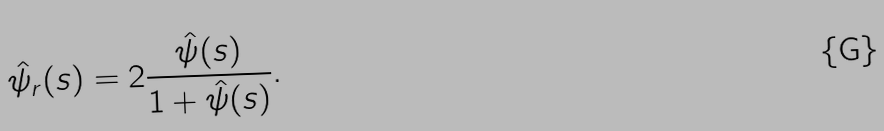<formula> <loc_0><loc_0><loc_500><loc_500>\hat { \psi } _ { r } ( s ) = 2 \frac { \hat { \psi } ( s ) } { 1 + \hat { \psi } ( s ) } .</formula> 